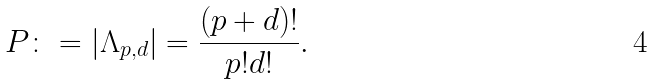<formula> <loc_0><loc_0><loc_500><loc_500>P \colon = | \Lambda _ { p , d } | = \frac { ( p + d ) ! } { p ! d ! } .</formula> 